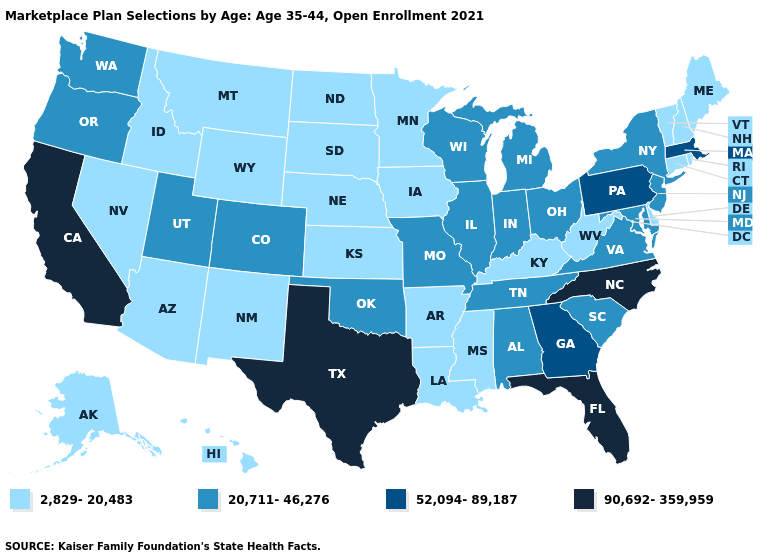What is the highest value in the USA?
Concise answer only. 90,692-359,959. Which states hav the highest value in the Northeast?
Short answer required. Massachusetts, Pennsylvania. Does North Carolina have the same value as Texas?
Keep it brief. Yes. What is the value of Illinois?
Concise answer only. 20,711-46,276. Which states have the highest value in the USA?
Write a very short answer. California, Florida, North Carolina, Texas. What is the value of Connecticut?
Short answer required. 2,829-20,483. Among the states that border West Virginia , does Pennsylvania have the lowest value?
Write a very short answer. No. Does West Virginia have the lowest value in the USA?
Write a very short answer. Yes. What is the value of Michigan?
Give a very brief answer. 20,711-46,276. What is the value of Missouri?
Write a very short answer. 20,711-46,276. Does the first symbol in the legend represent the smallest category?
Write a very short answer. Yes. What is the value of West Virginia?
Write a very short answer. 2,829-20,483. Which states have the highest value in the USA?
Quick response, please. California, Florida, North Carolina, Texas. Name the states that have a value in the range 90,692-359,959?
Concise answer only. California, Florida, North Carolina, Texas. What is the value of Washington?
Quick response, please. 20,711-46,276. 